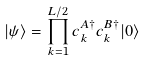<formula> <loc_0><loc_0><loc_500><loc_500>| \psi \rangle = \prod _ { k = 1 } ^ { L / 2 } { c _ { k } ^ { A \dagger } c _ { k } ^ { B \dagger } | 0 \rangle }</formula> 